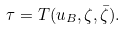Convert formula to latex. <formula><loc_0><loc_0><loc_500><loc_500>\tau = T ( u _ { B } , \zeta , \bar { \zeta } ) .</formula> 